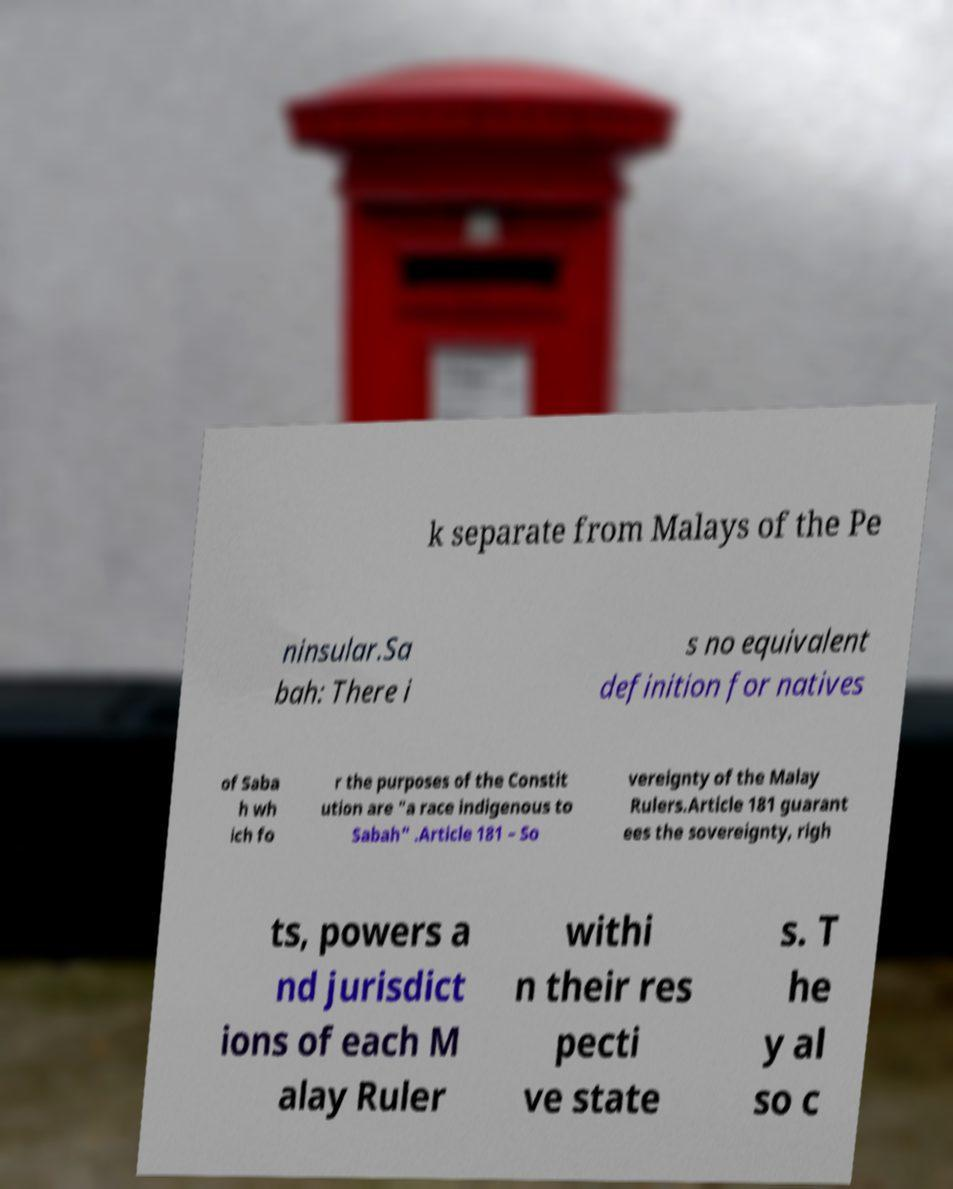Could you assist in decoding the text presented in this image and type it out clearly? k separate from Malays of the Pe ninsular.Sa bah: There i s no equivalent definition for natives of Saba h wh ich fo r the purposes of the Constit ution are "a race indigenous to Sabah" .Article 181 – So vereignty of the Malay Rulers.Article 181 guarant ees the sovereignty, righ ts, powers a nd jurisdict ions of each M alay Ruler withi n their res pecti ve state s. T he y al so c 